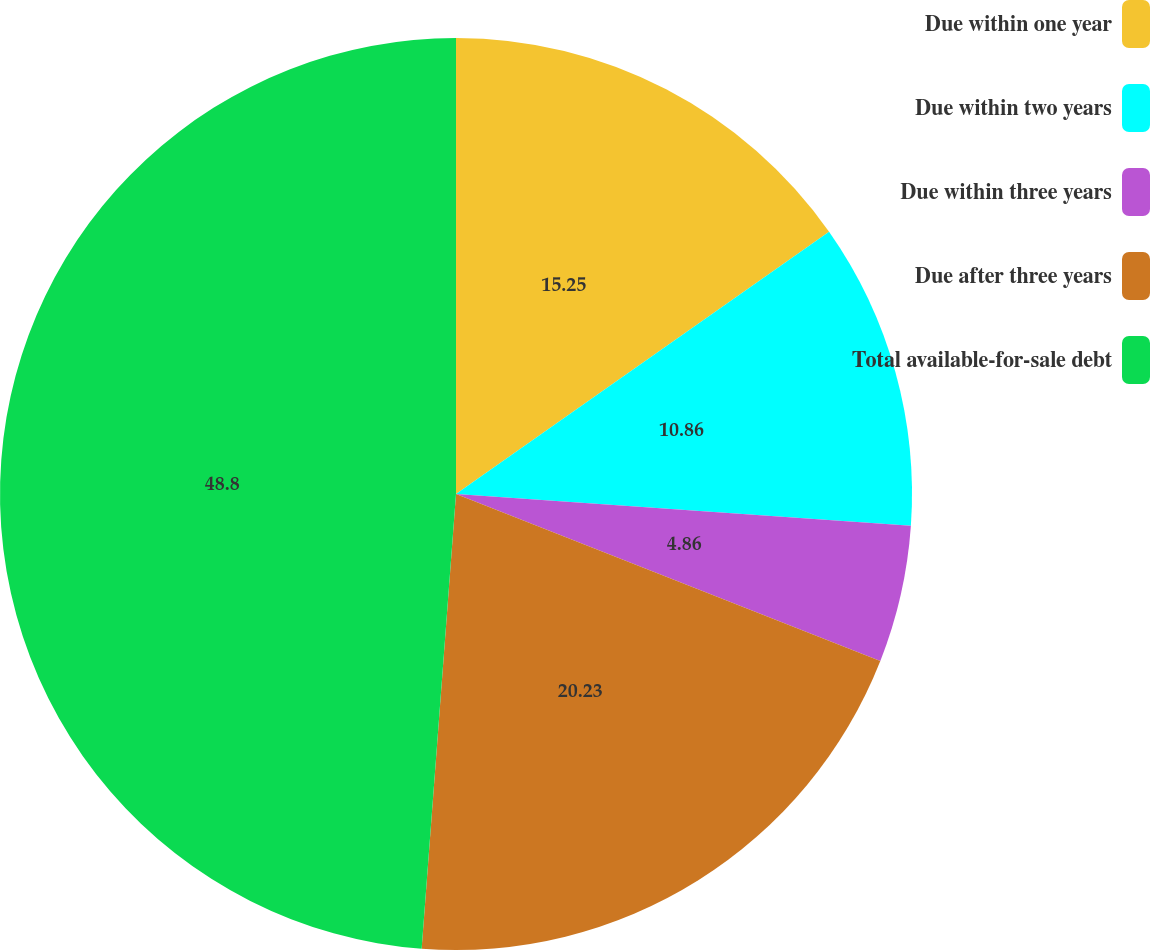Convert chart to OTSL. <chart><loc_0><loc_0><loc_500><loc_500><pie_chart><fcel>Due within one year<fcel>Due within two years<fcel>Due within three years<fcel>Due after three years<fcel>Total available-for-sale debt<nl><fcel>15.25%<fcel>10.86%<fcel>4.86%<fcel>20.23%<fcel>48.8%<nl></chart> 